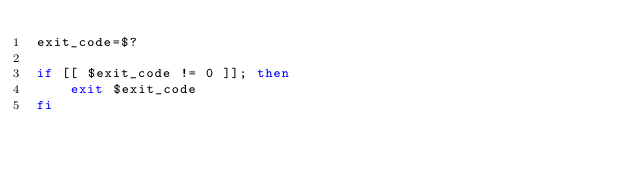Convert code to text. <code><loc_0><loc_0><loc_500><loc_500><_Bash_>exit_code=$?

if [[ $exit_code != 0 ]]; then
    exit $exit_code
fi
</code> 